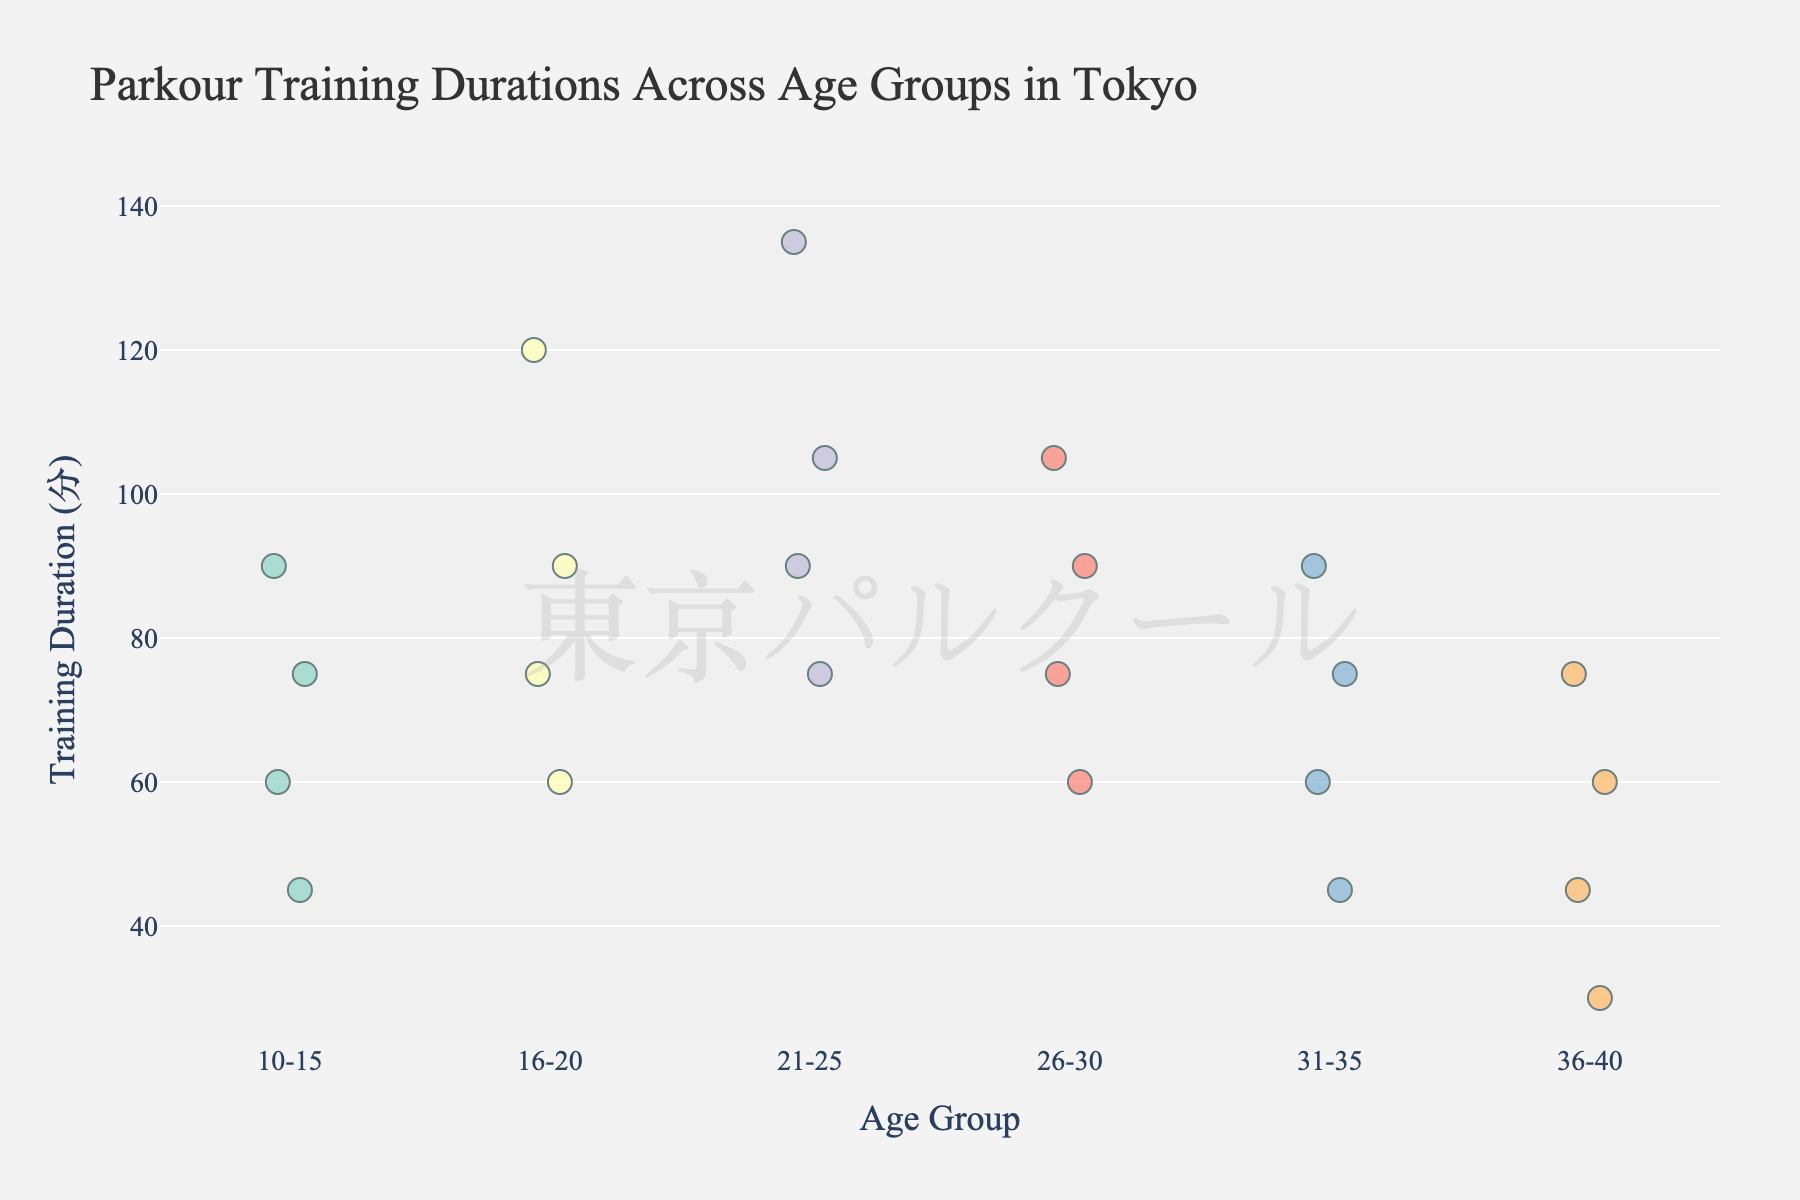How many age groups are represented in the plot? To determine the number of age groups in the plot, count the distinct categories along the x-axis labeled "Age Group".
Answer: 6 Which age group shows the widest range of training durations? To find the age group with the widest range, identify the group with the largest difference between the shortest and longest training durations by observing the vertical spread of points.
Answer: 21-25 What's the median training duration for the 26-30 age group? Order the training durations for the 26-30 age group: [60, 75, 90, 105]. Since the number of values is even, the median is the average of the two middle numbers: (75 + 90) / 2 = 82.5.
Answer: 82.5 Which age group has the shortest minimum training duration? Identify the lowest point in each age group. The age group with the lowest minimum point will have the shortest training duration.
Answer: 36-40 Is there any age group where the training duration extends beyond 100 minutes? Observe each age group for points that are above the 100-minute mark.
Answer: Yes What is the mean training duration for the 10-15 age group? Sum the training durations for the 10-15 age group: 45 + 60 + 75 + 90 = 270. Divide by the number of data points: 270 / 4 = 67.5.
Answer: 67.5 Which age group has the highest maximum training duration? Identify the topmost points in each age group. The age group with the highest point will have the highest maximum training duration.
Answer: 21-25 How many data points are there for the 16-20 age group? Count the individual markers for the 16-20 age group.
Answer: 4 Compare the median training durations of the 21-25 and 31-35 age groups. Which one is higher? First, find the medians. The median for 21-25 is the average of the middle two values [75, 90, 105, 135]: (90 + 105) / 2 = 97.5. The median for 31-35 is the average of the middle two values [45, 60, 75, 90]: (60 + 75) / 2 = 67.5. Compare the two medians: 97.5 vs. 67.5.
Answer: 21-25 Do any age groups have an outlier in their training durations? Identify any points that are noticeably separated from the rest of the data points for a given age group.
Answer: No 